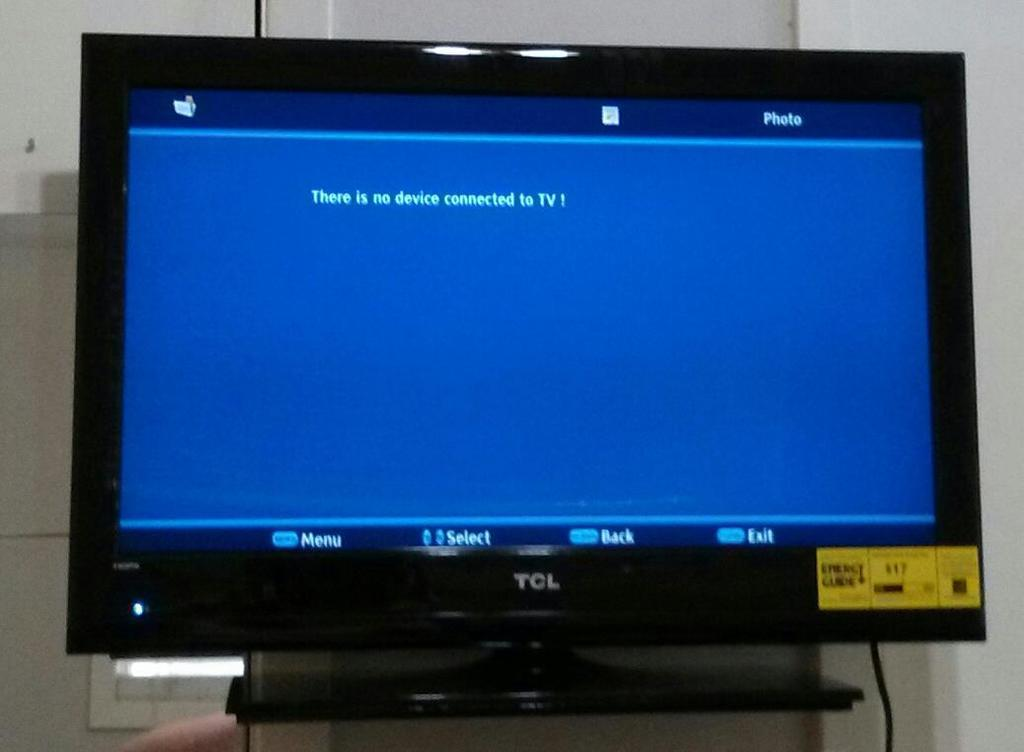<image>
Summarize the visual content of the image. a blue screen on a computer that says there is no device connected 